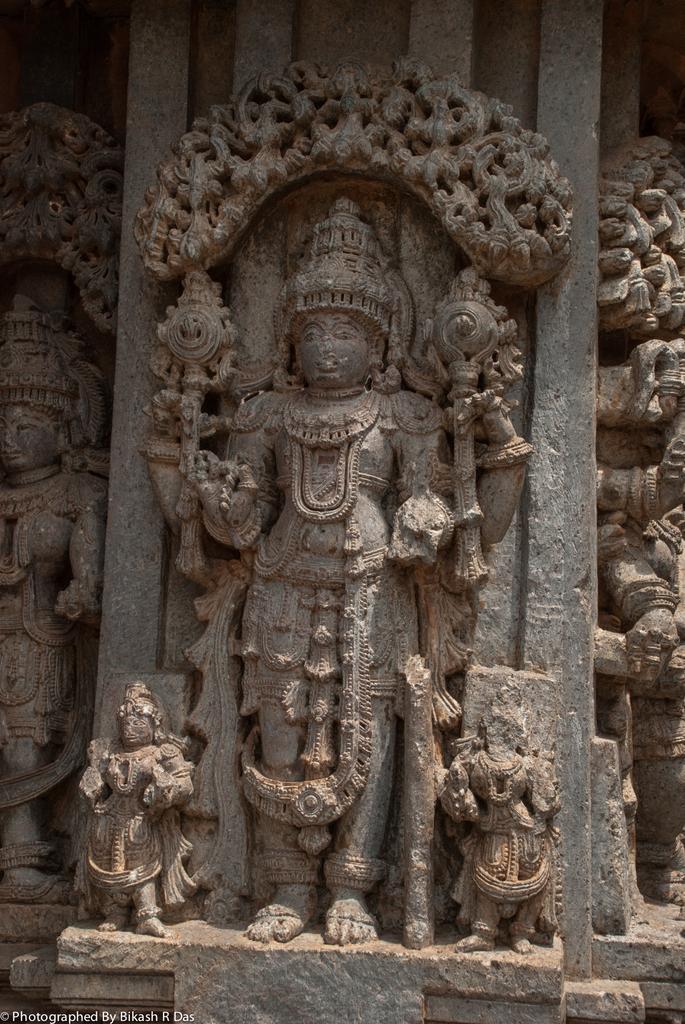Describe this image in one or two sentences. In the middle of this image, there are three sculptures on a wall. On the bottom left, there is a watermark. On the left side, there is a sculpture on the wall. On the right side, there are sculptures on the wall. 